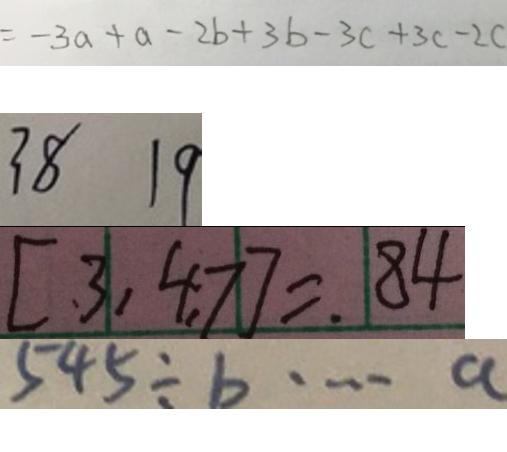<formula> <loc_0><loc_0><loc_500><loc_500>= - 3 a + a - 2 b + 3 b - 3 c + 3 c - 2 c 
 3 8 1 9 
 [ 3 , 4 , 7 ] = 8 4 
 5 4 5 \div b \cdots a</formula> 